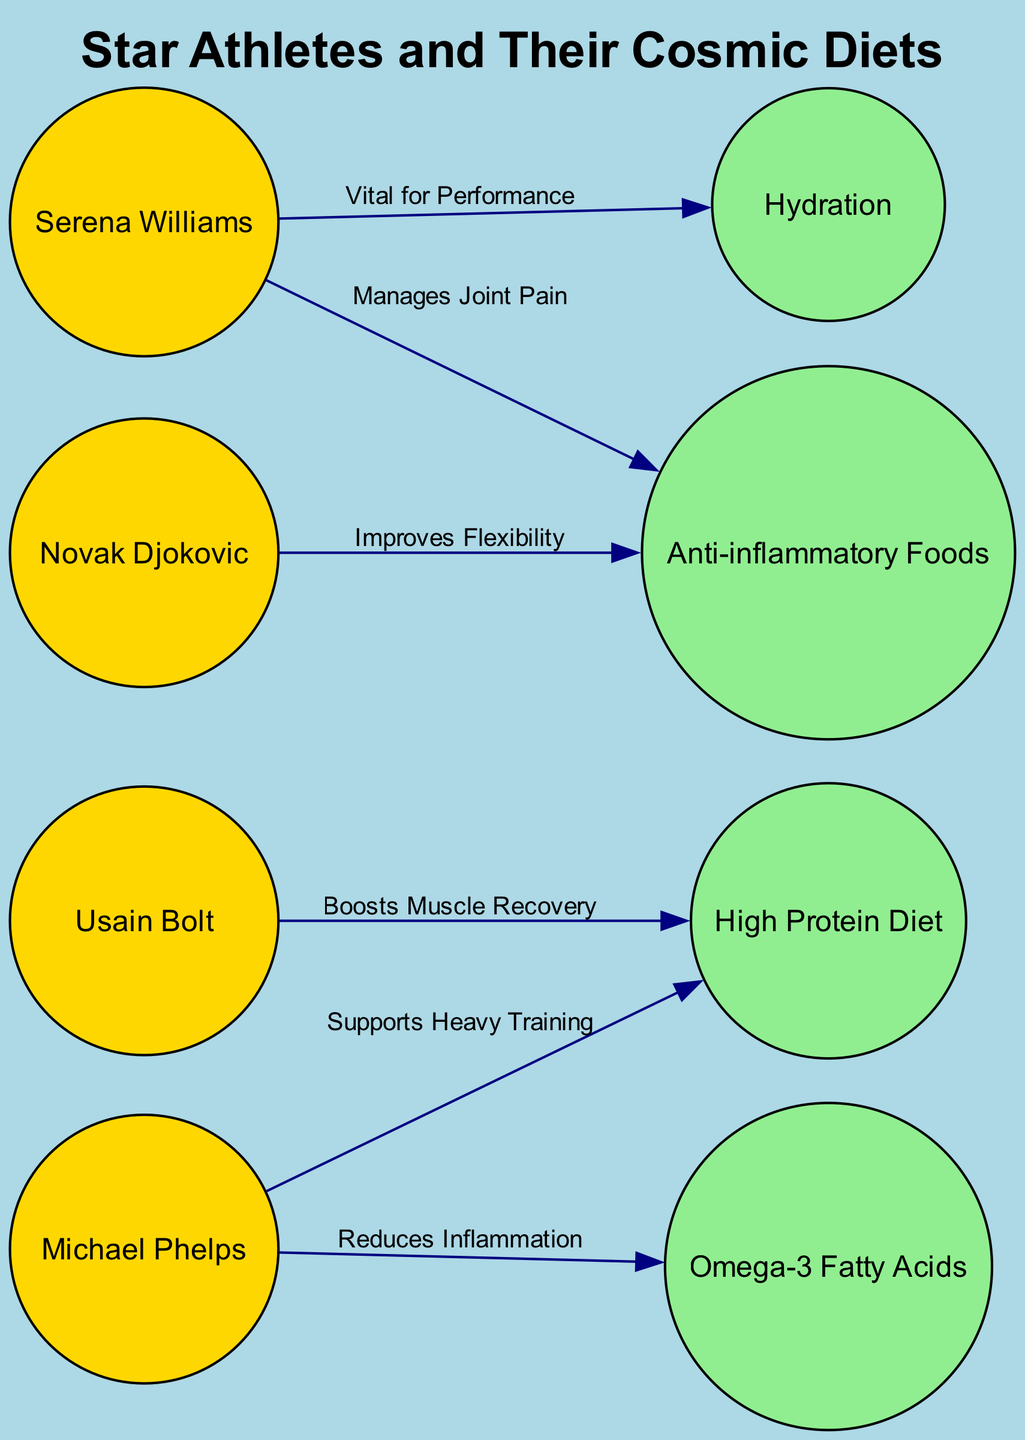What is the title of the diagram? The title is clearly labeled at the top of the diagram and is indicated in bold as "Star Athletes and Their Cosmic Diets."
Answer: Star Athletes and Their Cosmic Diets How many athletes are represented in the diagram? By counting the nodes labeled as athletes, we identify Usain Bolt, Michael Phelps, Serena Williams, and Novak Djokovic, totaling four athletes.
Answer: 4 Which diet is associated with Usain Bolt? The edge connecting Usain Bolt to "High Protein Diet" describes how this diet boosts his muscle recovery, clearly indicating that he follows a high protein diet.
Answer: High Protein Diet What is the relationship between Michael Phelps and Omega-3 Fatty Acids? There is a directed edge from Michael Phelps to Omega-3, with the label "Reduces Inflammation," indicating that this diet helps Phelps with inflammation reduction.
Answer: Reduces Inflammation Which athlete's diet emphasizes hydration? The edge from Serena Williams to "Hydration" shows that hydration is vital for her performance, implying she emphasizes this aspect in her diet.
Answer: Serena Williams How many types of diets are shown in the diagram? There are four distinct dietary nodes: High Protein Diet, Omega-3 Fatty Acids, Hydration, and Anti-inflammatory Foods, confirming that four types of diets are portrayed.
Answer: 4 Which athlete uses anti-inflammatory foods to manage joint pain? The edge from Serena Williams to "Anti-inflammatory Foods" specifies that this diet helps manage her joint pain, making her the athlete that utilizes it for this purpose.
Answer: Serena Williams What is the effect of a high protein diet for Michael Phelps? The connection from Michael Phelps to "High Protein Diet" states that it "Supports Heavy Training," demonstrating the diet's positive effect on his training regimen.
Answer: Supports Heavy Training Which diet improves flexibility for Novak Djokovic? The edge from Novak Djokovic to "Anti-inflammatory Foods" mentions that this diet improves his flexibility, indicating its role in his athletic performance.
Answer: Improves Flexibility 